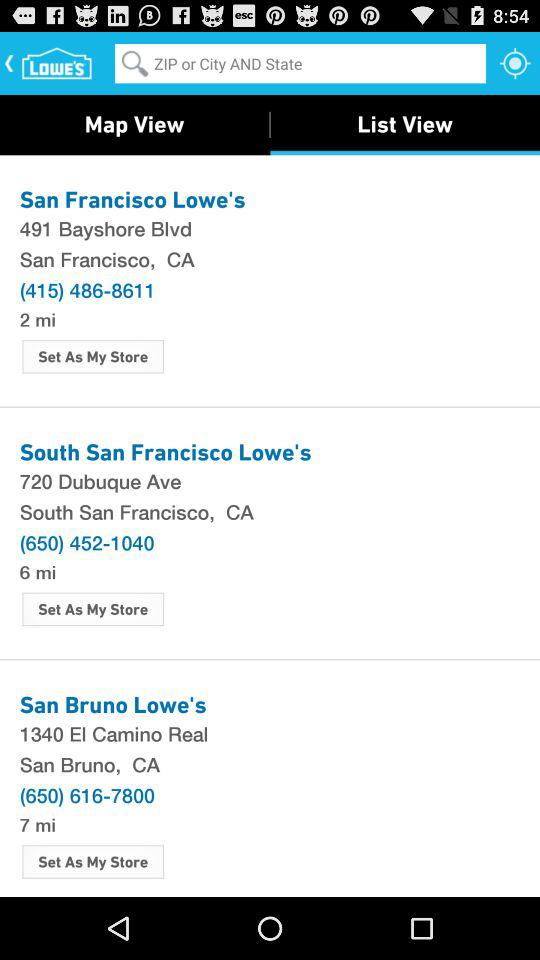What is the distance of the "South San Francisco Lowe's"? The distance is 6 miles. 